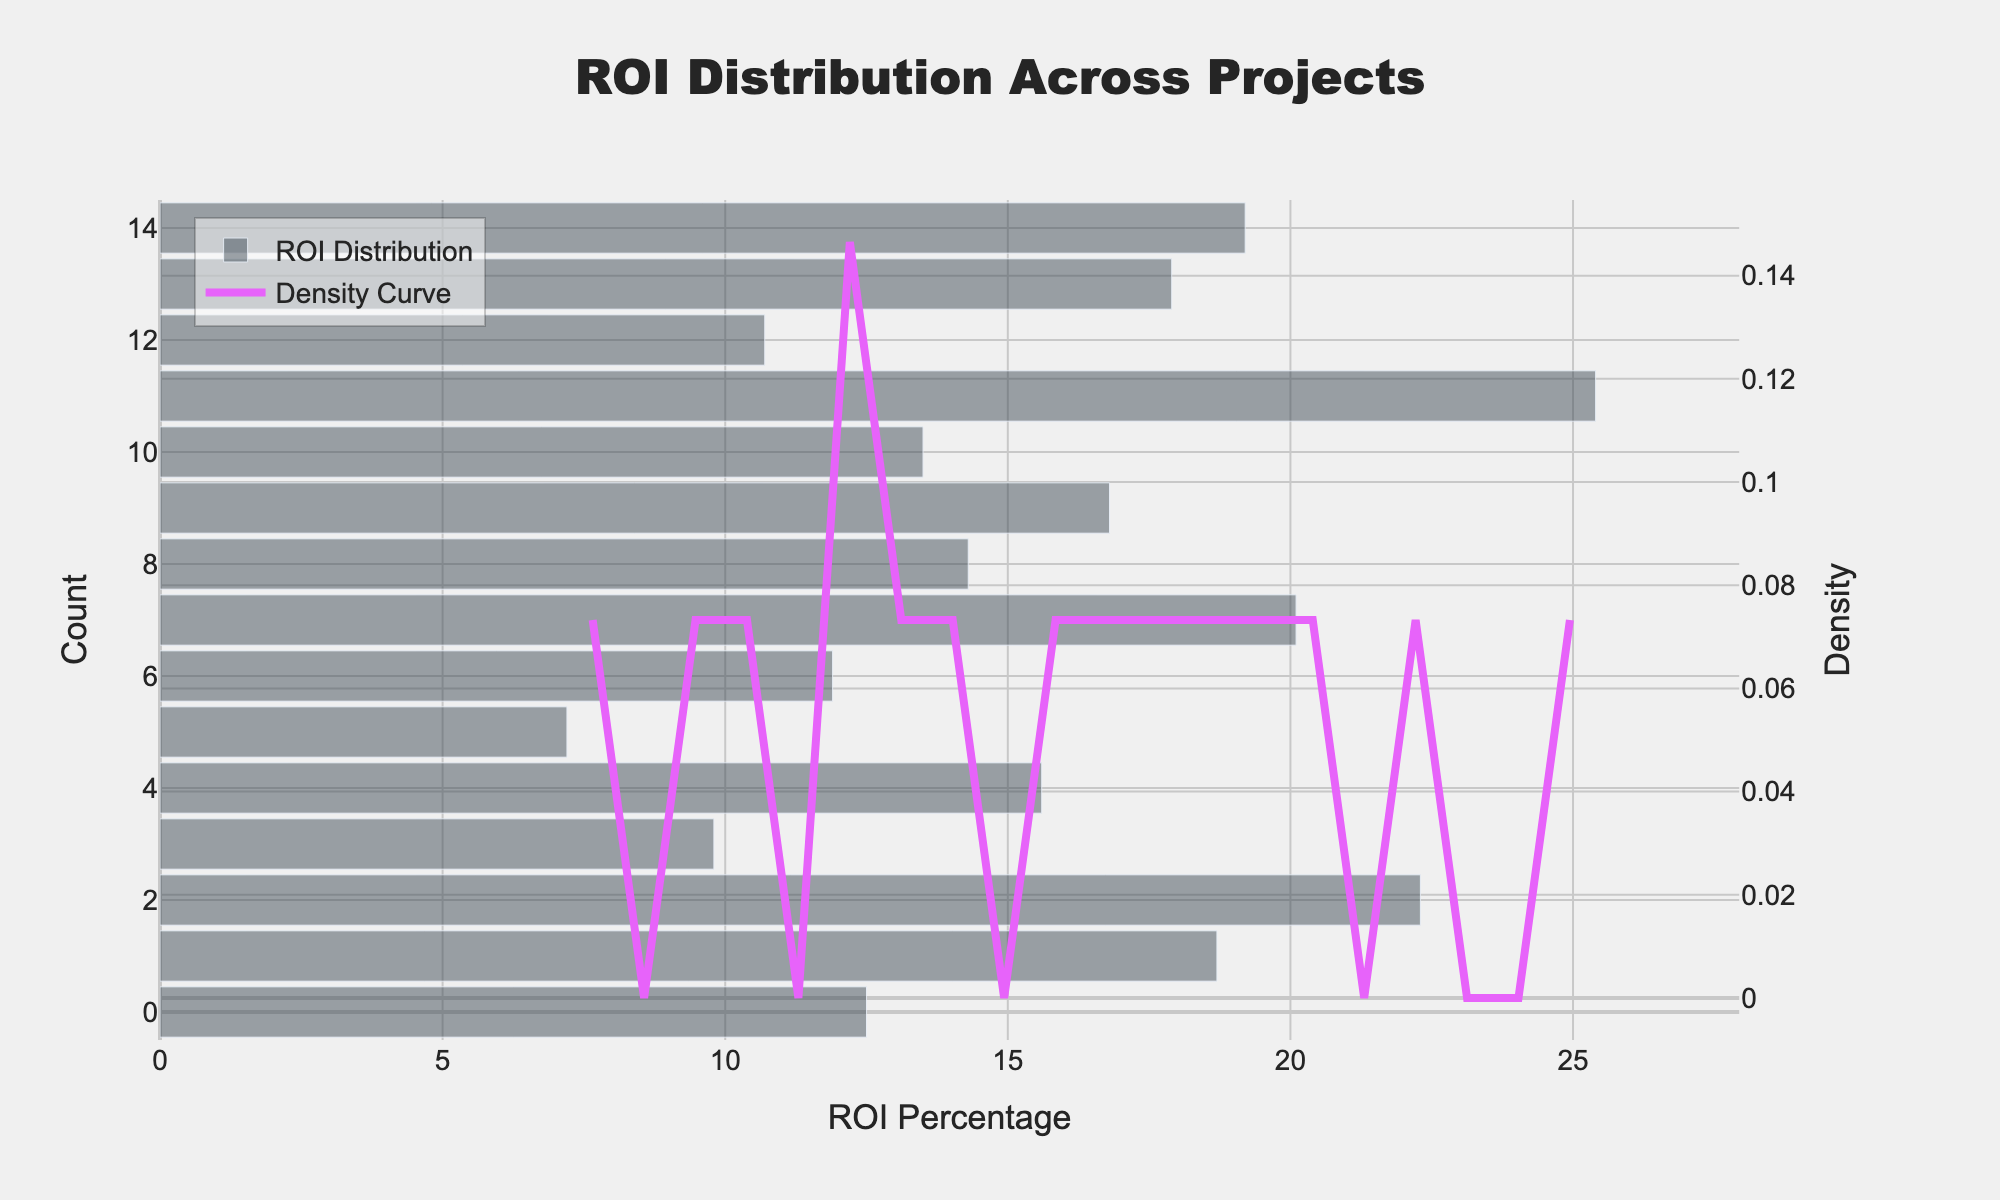How many projects have an ROI above 20%? Count the data points in the histogram where ROI is above 20%. There are 3 data points (New Product Development - Fintech App, Research and Development - AI Integration, Automated Reporting Tool).
Answer: 3 What's the title of the plot? The title is located at the top of the plot.
Answer: ROI Distribution Across Projects What is the range of the x-axis? The x-axis range can be determined from the axis scale and the data points. The scale shows from 0 to approximately 27.
Answer: 0 to 27 Which project has the highest ROI? Identify the highest ROI value in the dataset, which is 25.4%, and find the corresponding project.
Answer: Research and Development - AI Integration What is the median ROI percentage for the projects? First, list all the ROI values in order: 7.2, 9.8, 10.7, 11.9, 12.5, 13.5, 14.3, 15.6, 16.8, 17.9, 18.7, 19.2, 20.1, 22.3, 25.4. The middle value is the eighth one in this ordered list.
Answer: 15.6 Which project has the lowest ROI? Identify the smallest ROI value in the dataset, which is 7.2%, and find the corresponding project.
Answer: Office Expansion What is the average ROI across all projects? Sum all ROI values and divide by the number of projects. Calculation: (12.5 + 18.7 + 22.3 + 9.8 + 15.6 + 7.2 + 11.9 + 20.1 + 14.3 + 16.8 + 13.5 + 25.4 + 10.7 + 17.9 + 19.2) / 15 = 16.0%
Answer: 16.0% What does the secondary y-axis represent? The secondary y-axis is the right-side y-axis which represents the density of the KDE curve.
Answer: Density Which ROI range has the highest density according to the KDE? Look at the peak of the density curve, which is between approximately 15% and 20%.
Answer: 15% to 20% How many histogram bars are used in the plot? Count the histogram bars present in the visual. The number of bars matches the number of projects, which is 15.
Answer: 15 